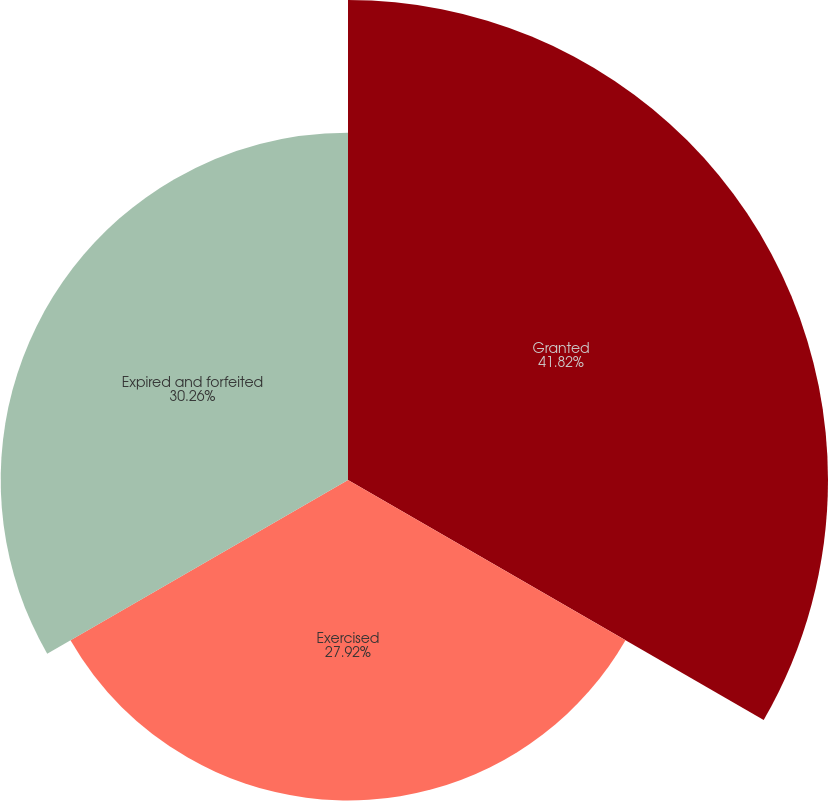Convert chart. <chart><loc_0><loc_0><loc_500><loc_500><pie_chart><fcel>Granted<fcel>Exercised<fcel>Expired and forfeited<nl><fcel>41.82%<fcel>27.92%<fcel>30.26%<nl></chart> 